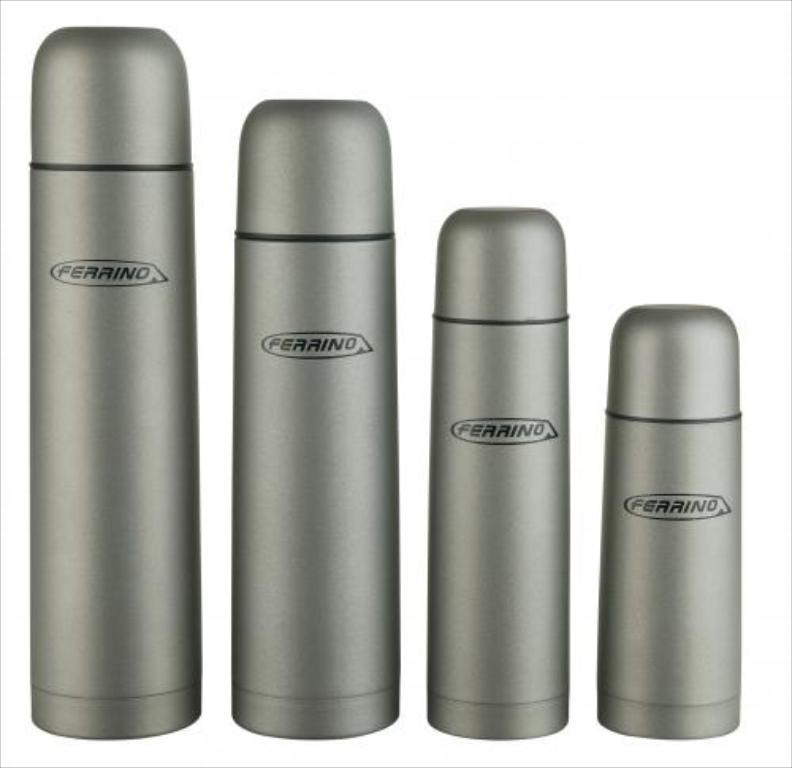Provide a one-sentence caption for the provided image. Four canisters of different sizes are labeled with the name Ferrino. 